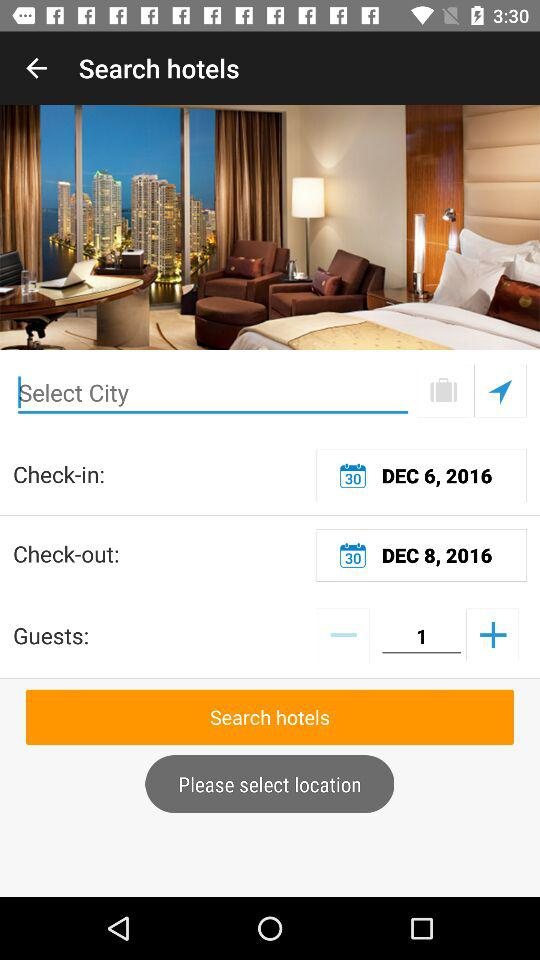What is the check-out date? The check-out date is December 8, 2016. 